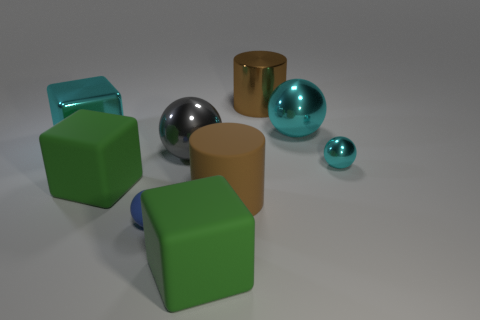What is the color of the shiny block?
Provide a short and direct response. Cyan. What is the shape of the object that is the same color as the large rubber cylinder?
Provide a short and direct response. Cylinder. There is another sphere that is the same size as the gray ball; what color is it?
Ensure brevity in your answer.  Cyan. How many metal objects are large yellow things or large cyan blocks?
Provide a short and direct response. 1. How many large objects are behind the tiny cyan metallic object and in front of the blue sphere?
Your answer should be very brief. 0. Are there any other things that are the same shape as the big gray object?
Provide a short and direct response. Yes. How many other things are there of the same size as the cyan cube?
Your answer should be compact. 6. There is a cyan metal ball behind the small cyan metallic sphere; is it the same size as the rubber thing in front of the blue ball?
Your answer should be very brief. Yes. What number of objects are either large brown metal objects or cyan metallic things that are on the right side of the blue thing?
Ensure brevity in your answer.  3. There is a brown object in front of the brown shiny object; how big is it?
Ensure brevity in your answer.  Large. 